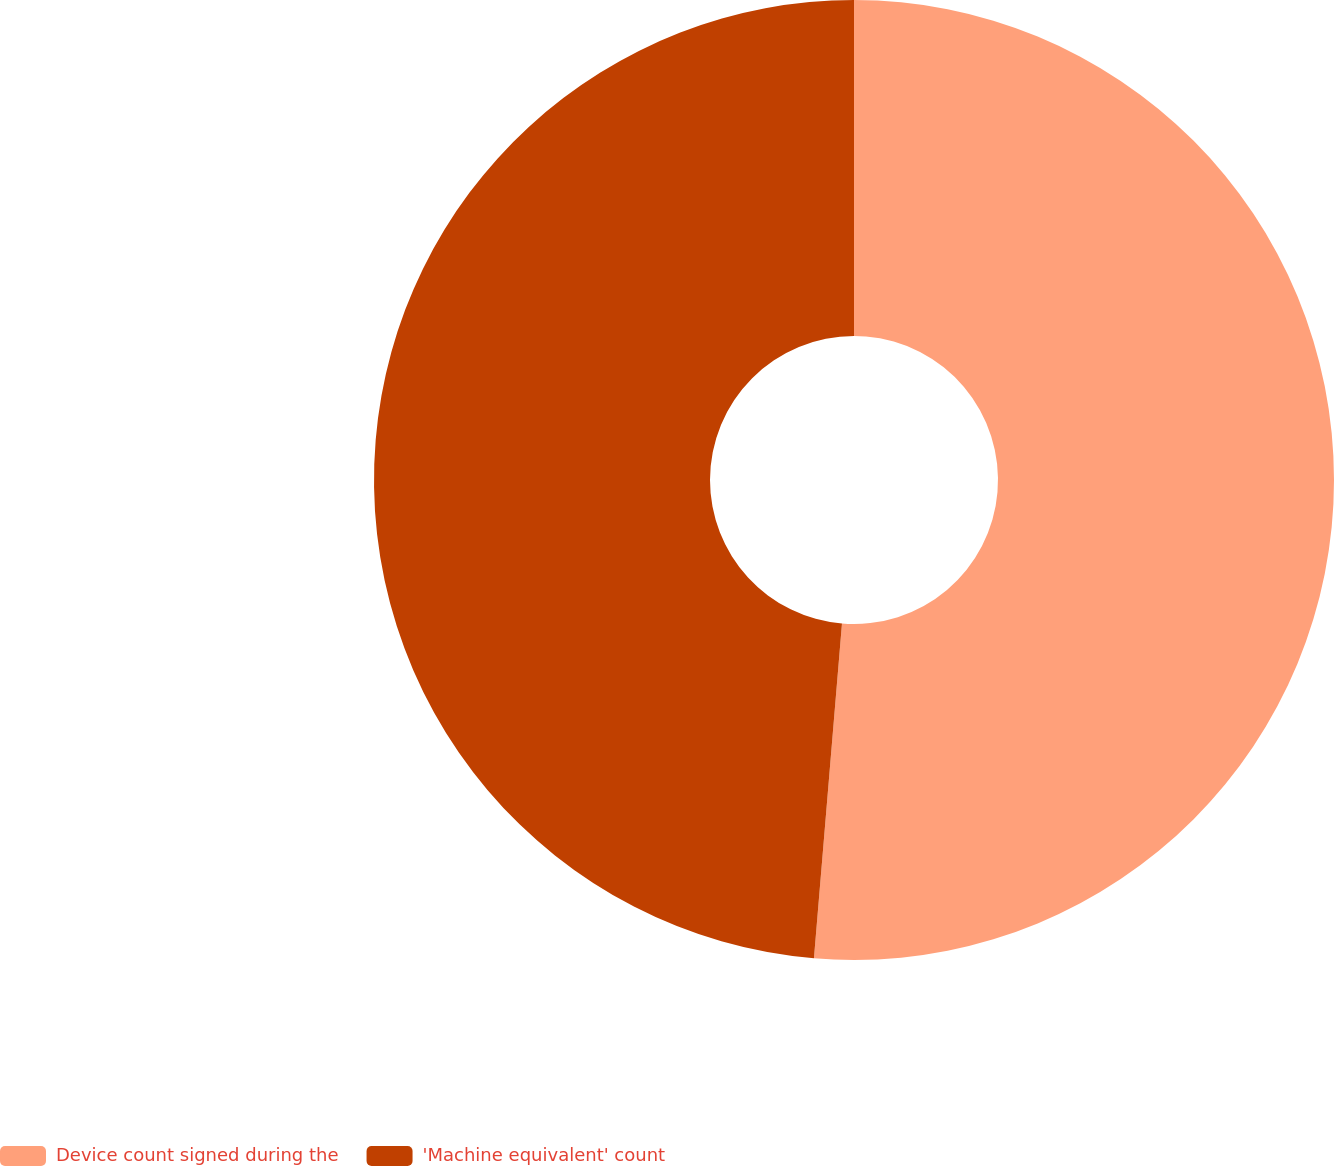<chart> <loc_0><loc_0><loc_500><loc_500><pie_chart><fcel>Device count signed during the<fcel>'Machine equivalent' count<nl><fcel>51.33%<fcel>48.67%<nl></chart> 